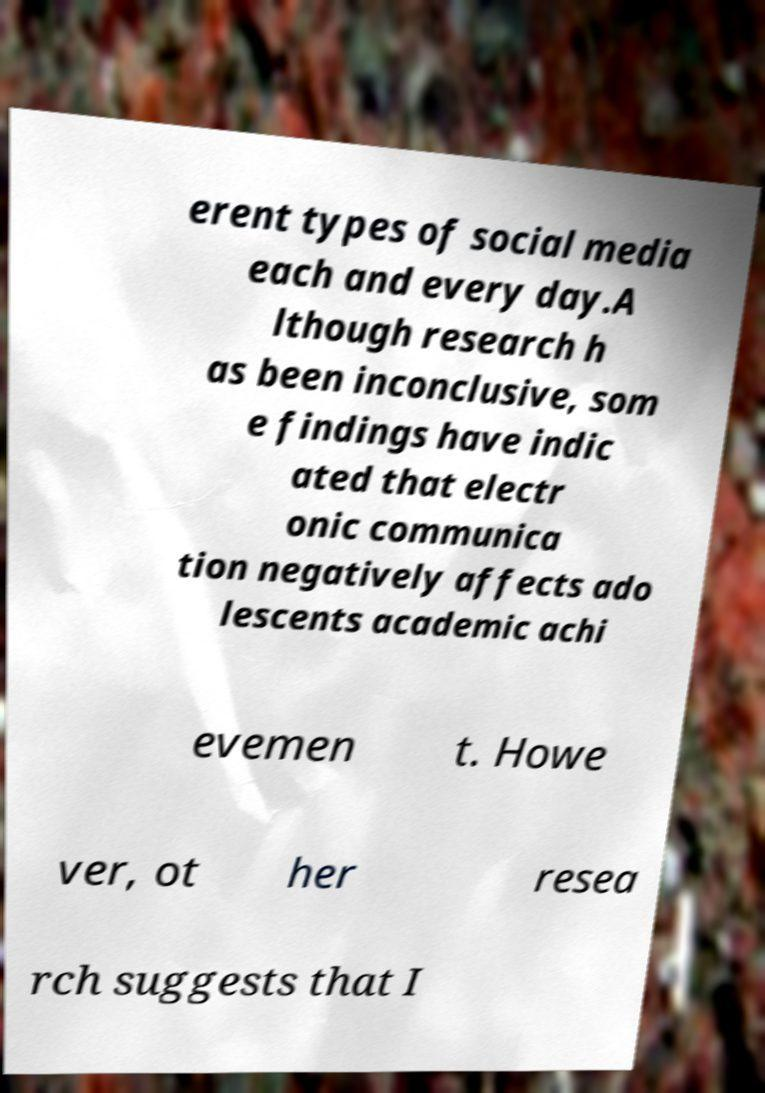Please read and relay the text visible in this image. What does it say? erent types of social media each and every day.A lthough research h as been inconclusive, som e findings have indic ated that electr onic communica tion negatively affects ado lescents academic achi evemen t. Howe ver, ot her resea rch suggests that I 